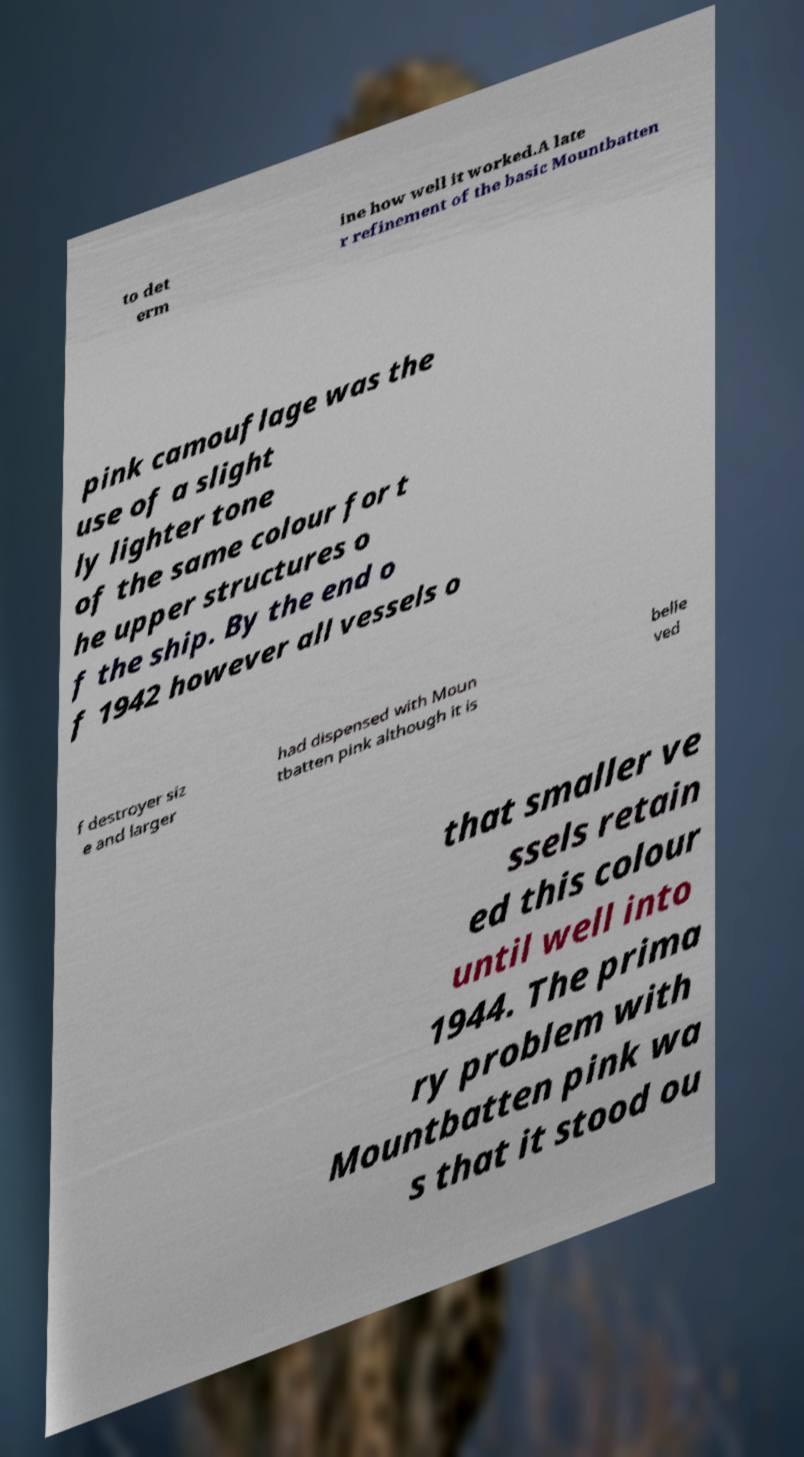Please identify and transcribe the text found in this image. to det erm ine how well it worked.A late r refinement of the basic Mountbatten pink camouflage was the use of a slight ly lighter tone of the same colour for t he upper structures o f the ship. By the end o f 1942 however all vessels o f destroyer siz e and larger had dispensed with Moun tbatten pink although it is belie ved that smaller ve ssels retain ed this colour until well into 1944. The prima ry problem with Mountbatten pink wa s that it stood ou 